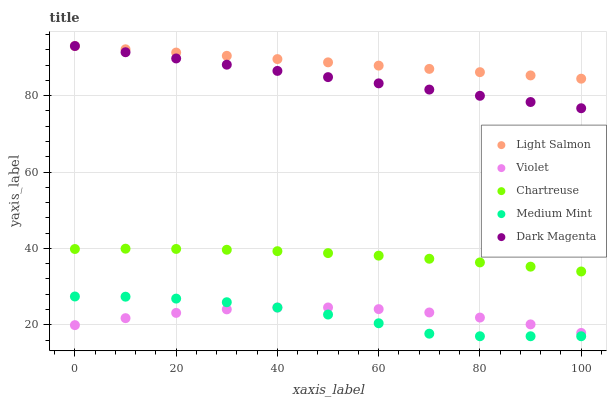Does Medium Mint have the minimum area under the curve?
Answer yes or no. Yes. Does Light Salmon have the maximum area under the curve?
Answer yes or no. Yes. Does Chartreuse have the minimum area under the curve?
Answer yes or no. No. Does Chartreuse have the maximum area under the curve?
Answer yes or no. No. Is Light Salmon the smoothest?
Answer yes or no. Yes. Is Medium Mint the roughest?
Answer yes or no. Yes. Is Chartreuse the smoothest?
Answer yes or no. No. Is Chartreuse the roughest?
Answer yes or no. No. Does Medium Mint have the lowest value?
Answer yes or no. Yes. Does Chartreuse have the lowest value?
Answer yes or no. No. Does Dark Magenta have the highest value?
Answer yes or no. Yes. Does Chartreuse have the highest value?
Answer yes or no. No. Is Medium Mint less than Chartreuse?
Answer yes or no. Yes. Is Chartreuse greater than Medium Mint?
Answer yes or no. Yes. Does Light Salmon intersect Dark Magenta?
Answer yes or no. Yes. Is Light Salmon less than Dark Magenta?
Answer yes or no. No. Is Light Salmon greater than Dark Magenta?
Answer yes or no. No. Does Medium Mint intersect Chartreuse?
Answer yes or no. No. 